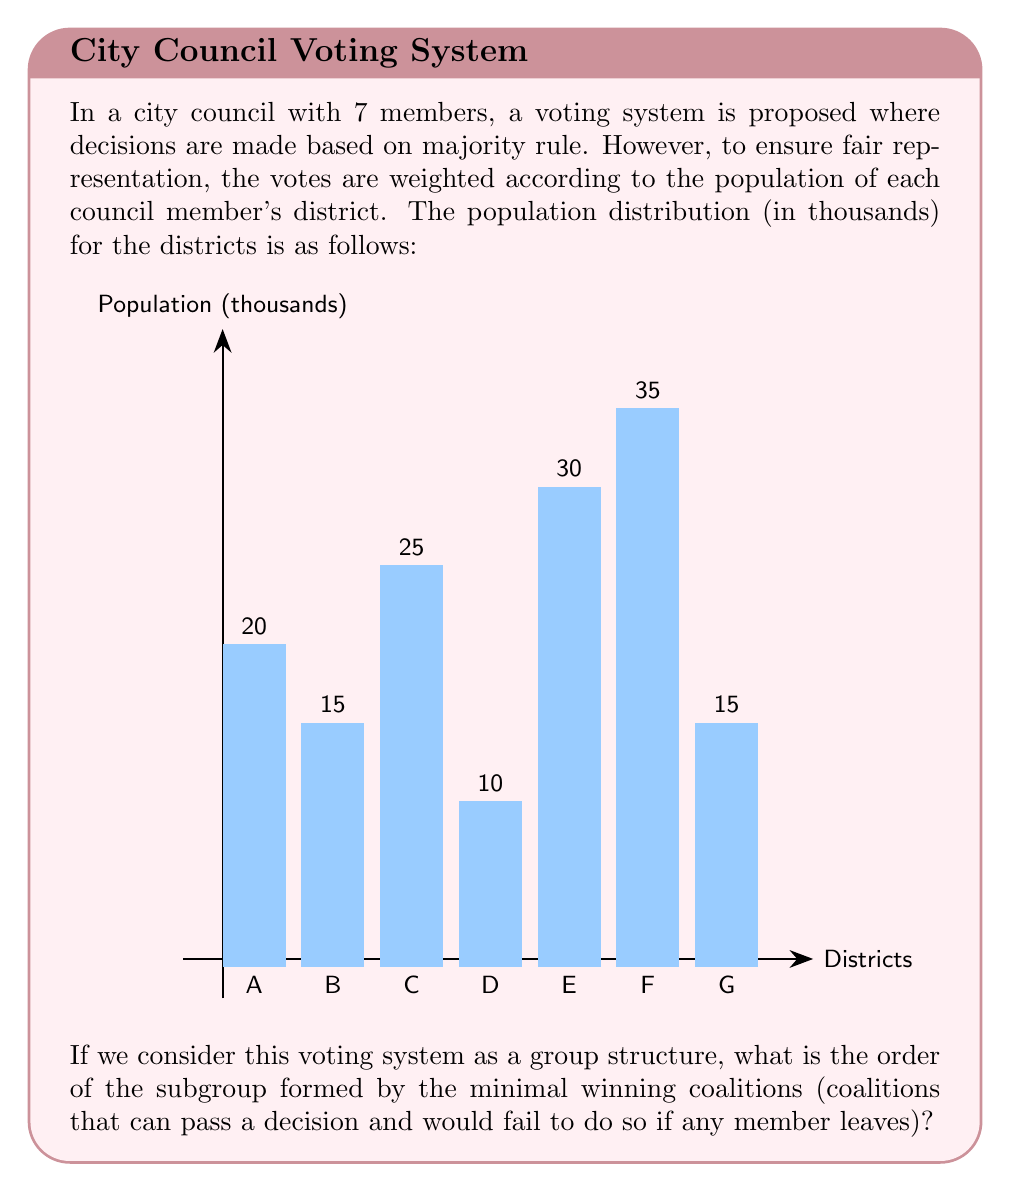Can you solve this math problem? Let's approach this step-by-step:

1) First, we need to calculate the total population:
   $20 + 15 + 25 + 10 + 30 + 35 + 15 = 150$ thousand

2) A majority would be any coalition with more than half of the total population:
   $150/2 = 75$ thousand

3) Now, we need to find all minimal winning coalitions. These are coalitions that:
   a) Have more than 75 thousand population
   b) Would fall below 75 thousand if any member leaves

4) Let's list all such coalitions:
   - F + E + C = 35 + 30 + 25 = 90
   - F + E + A = 35 + 30 + 20 = 85
   - F + C + A = 35 + 25 + 20 = 80
   - F + E + B + G = 35 + 30 + 15 + 15 = 95
   - F + C + B + G = 35 + 25 + 15 + 15 = 90
   - E + C + A + B = 30 + 25 + 20 + 15 = 90
   - E + C + A + G = 30 + 25 + 20 + 15 = 90

5) Each of these coalitions forms an element in our subgroup of minimal winning coalitions.

6) The order of a group is the number of elements it contains. In this case, we have 7 minimal winning coalitions.

Therefore, the order of the subgroup formed by the minimal winning coalitions is 7.
Answer: 7 